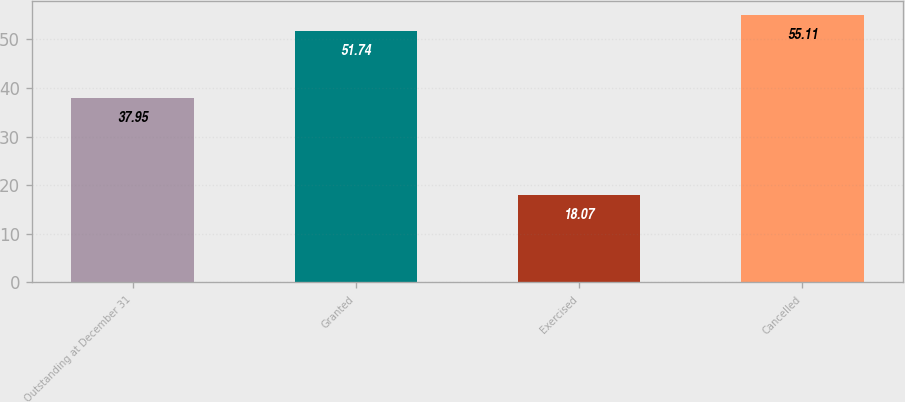Convert chart to OTSL. <chart><loc_0><loc_0><loc_500><loc_500><bar_chart><fcel>Outstanding at December 31<fcel>Granted<fcel>Exercised<fcel>Cancelled<nl><fcel>37.95<fcel>51.74<fcel>18.07<fcel>55.11<nl></chart> 